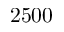<formula> <loc_0><loc_0><loc_500><loc_500>2 5 0 0</formula> 